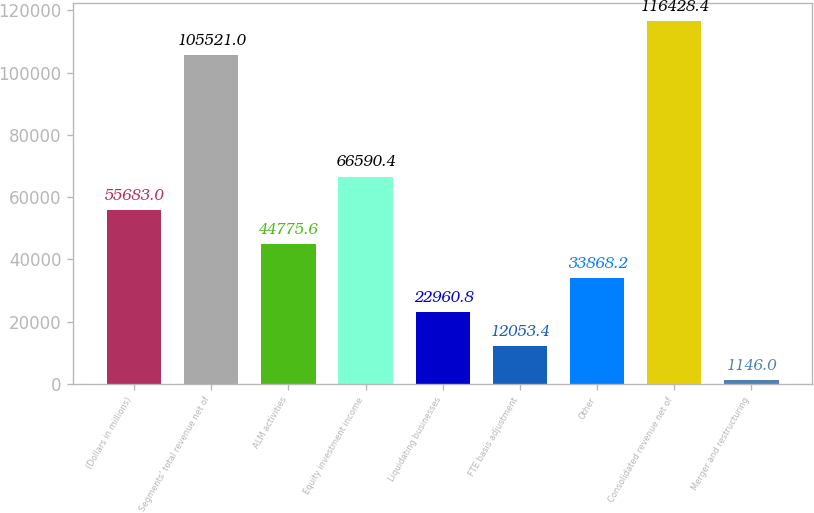Convert chart to OTSL. <chart><loc_0><loc_0><loc_500><loc_500><bar_chart><fcel>(Dollars in millions)<fcel>Segments' total revenue net of<fcel>ALM activities<fcel>Equity investment income<fcel>Liquidating businesses<fcel>FTE basis adjustment<fcel>Other<fcel>Consolidated revenue net of<fcel>Merger and restructuring<nl><fcel>55683<fcel>105521<fcel>44775.6<fcel>66590.4<fcel>22960.8<fcel>12053.4<fcel>33868.2<fcel>116428<fcel>1146<nl></chart> 